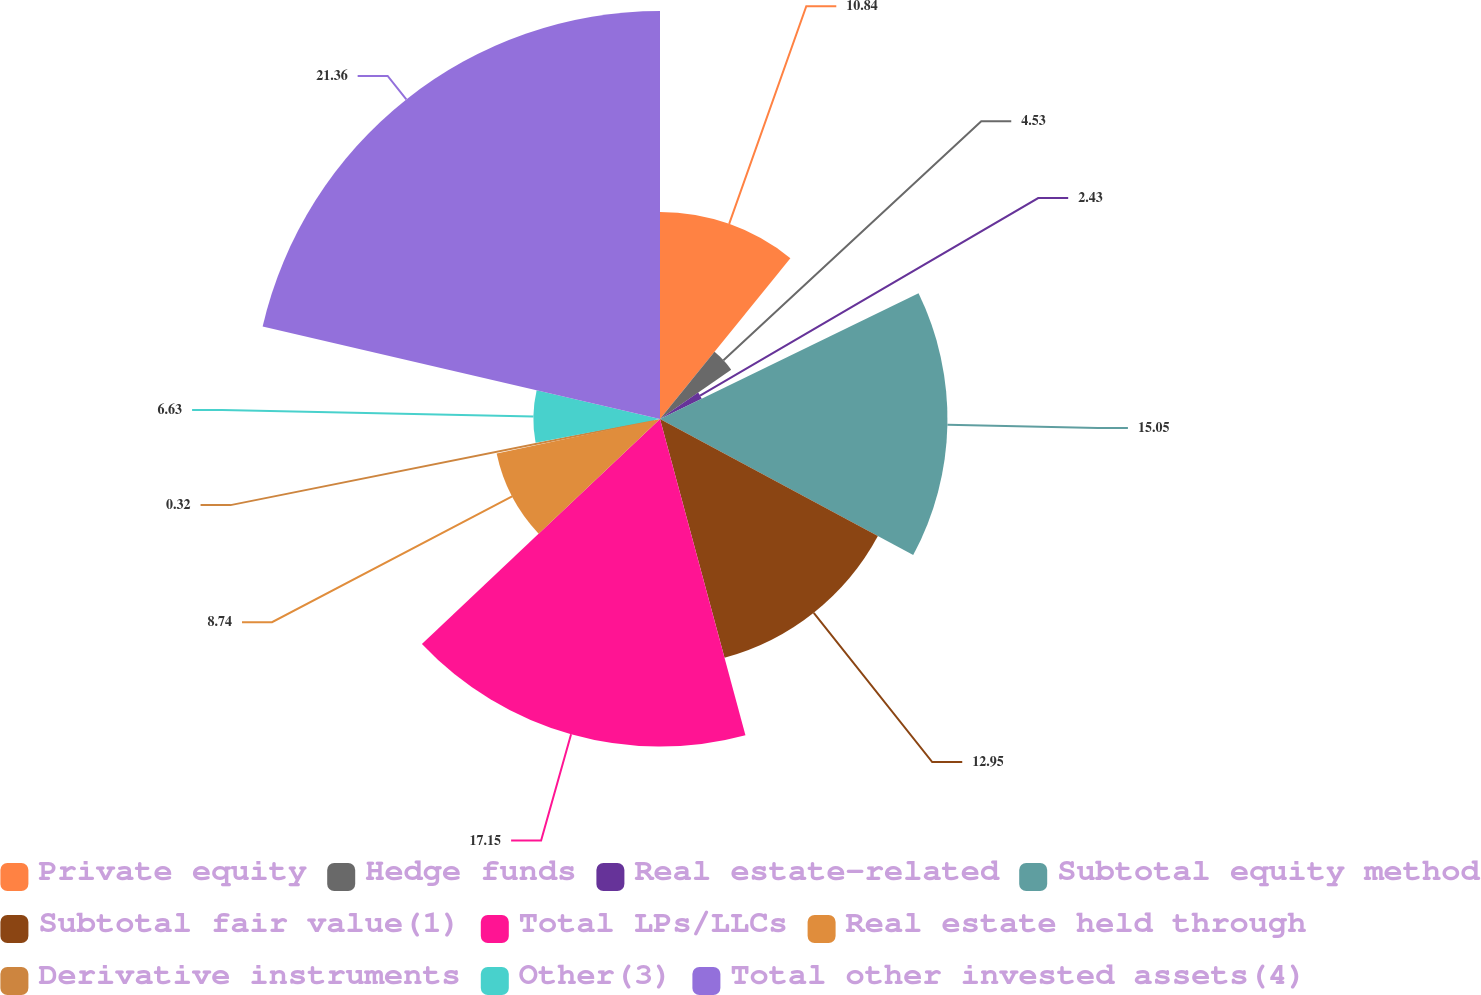<chart> <loc_0><loc_0><loc_500><loc_500><pie_chart><fcel>Private equity<fcel>Hedge funds<fcel>Real estate-related<fcel>Subtotal equity method<fcel>Subtotal fair value(1)<fcel>Total LPs/LLCs<fcel>Real estate held through<fcel>Derivative instruments<fcel>Other(3)<fcel>Total other invested assets(4)<nl><fcel>10.84%<fcel>4.53%<fcel>2.43%<fcel>15.05%<fcel>12.95%<fcel>17.15%<fcel>8.74%<fcel>0.32%<fcel>6.63%<fcel>21.36%<nl></chart> 